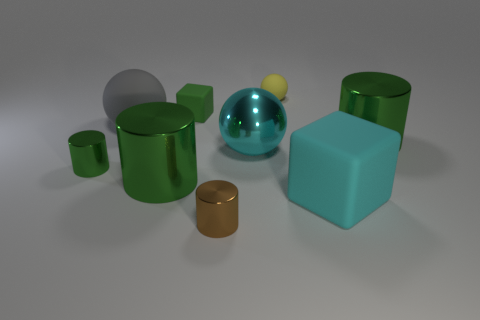Subtract all blue blocks. How many green cylinders are left? 3 Subtract all yellow cylinders. Subtract all green spheres. How many cylinders are left? 4 Add 1 large green metallic cylinders. How many objects exist? 10 Subtract all blocks. How many objects are left? 7 Subtract 0 purple spheres. How many objects are left? 9 Subtract all big green objects. Subtract all brown metallic cylinders. How many objects are left? 6 Add 1 gray balls. How many gray balls are left? 2 Add 6 cyan spheres. How many cyan spheres exist? 7 